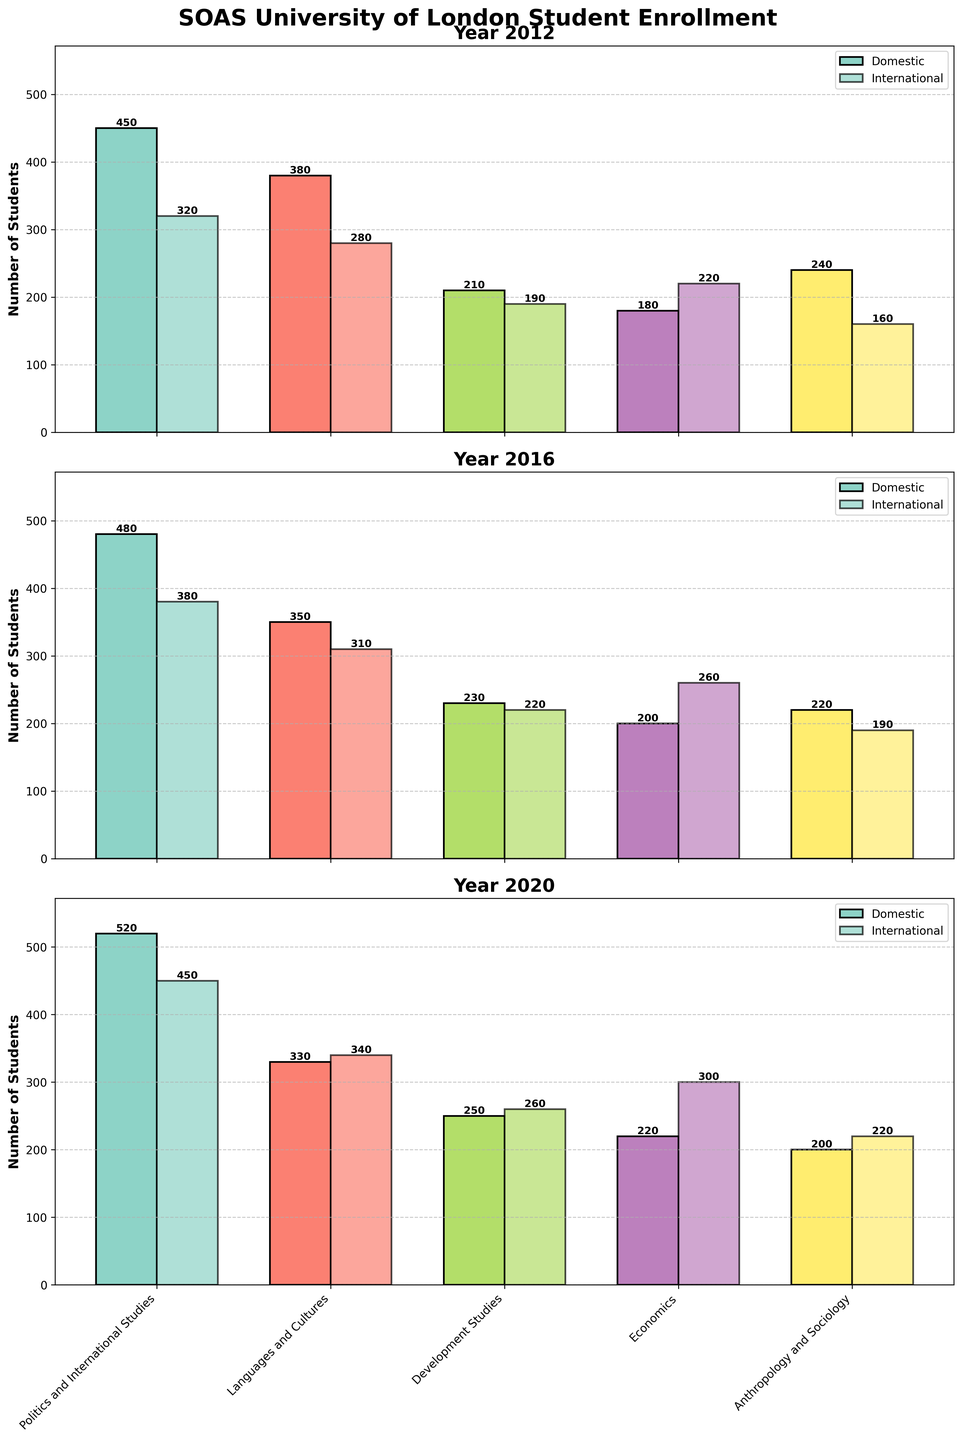What is the title of the plot? The title of the plot is displayed prominently at the top and provides a summary of what the data visualization is about. The title reads "SOAS University of London Student Enrollment".
Answer: SOAS University of London Student Enrollment How many years of data are displayed in the plot? There are individual subplots for each year of data. By counting the number of subplots, we can determine that there are three years displayed: 2012, 2016, and 2020.
Answer: 3 Which department had the most international students in 2020? To find this, we look at the subplot for the year 2020. Among all the bars labeled for international students, the highest bar corresponds to the Economics department.
Answer: Economics What is the difference in the number of domestic students between the Politics and International Studies department in 2012 and 2020? By looking at the bars for domestic students in the Politics and International Studies department in 2012 and 2020, we see 450 and 520 respectively. The difference is 520 - 450 = 70.
Answer: 70 How many international students were enrolled in the Development Studies department in 2016? We find the relevant subplot for 2016 and identify the bar for international students in the Development Studies department. The number shown is 220.
Answer: 220 Which year had the highest enrollment of domestic students in the Languages and Cultures department? We compare the heights of the bars for domestic students in the Languages and Cultures department across the subplots for 2012, 2016, and 2020. The highest enrollment occurred in 2012 with 380 students.
Answer: 2012 What is the total number of students (domestic and international) in the Anthropology and Sociology department in 2016? We add the domestic and international students for the Anthropology and Sociology department in 2016 by looking at the subplot for 2016. The numbers are 220 (domestic) and 190 (international), so the total is 220 + 190 = 410.
Answer: 410 Which year shows an increase in both domestic and international students in the Economics department compared to the previous year shown? Comparing 2012 to 2016 and 2016 to 2020 subplots, we notice that the number of students in both domestic and international categories increased from 2016 to 2020 in the Economics department (200 vs. 220 for domestic, 260 vs. 300 for international).
Answer: 2020 What is the average number of domestic students per department in 2020? We sum the number of domestic students across all departments in 2020 and divide by the number of departments. The sum is 520 + 330 + 250 + 220 + 200 = 1520. There are 5 departments, so the average is 1520 / 5 = 304.
Answer: 304 Which department showed the greatest increase in international students from 2012 to 2016? Comparing the number of international students in each department between 2012 and 2016, the Politics and International Studies department has the largest increase from 320 to 380, which is an increase of 60 students.
Answer: Politics and International Studies 